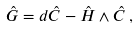Convert formula to latex. <formula><loc_0><loc_0><loc_500><loc_500>\hat { G } = d \hat { C } - \hat { H } \wedge \hat { C } \, ,</formula> 